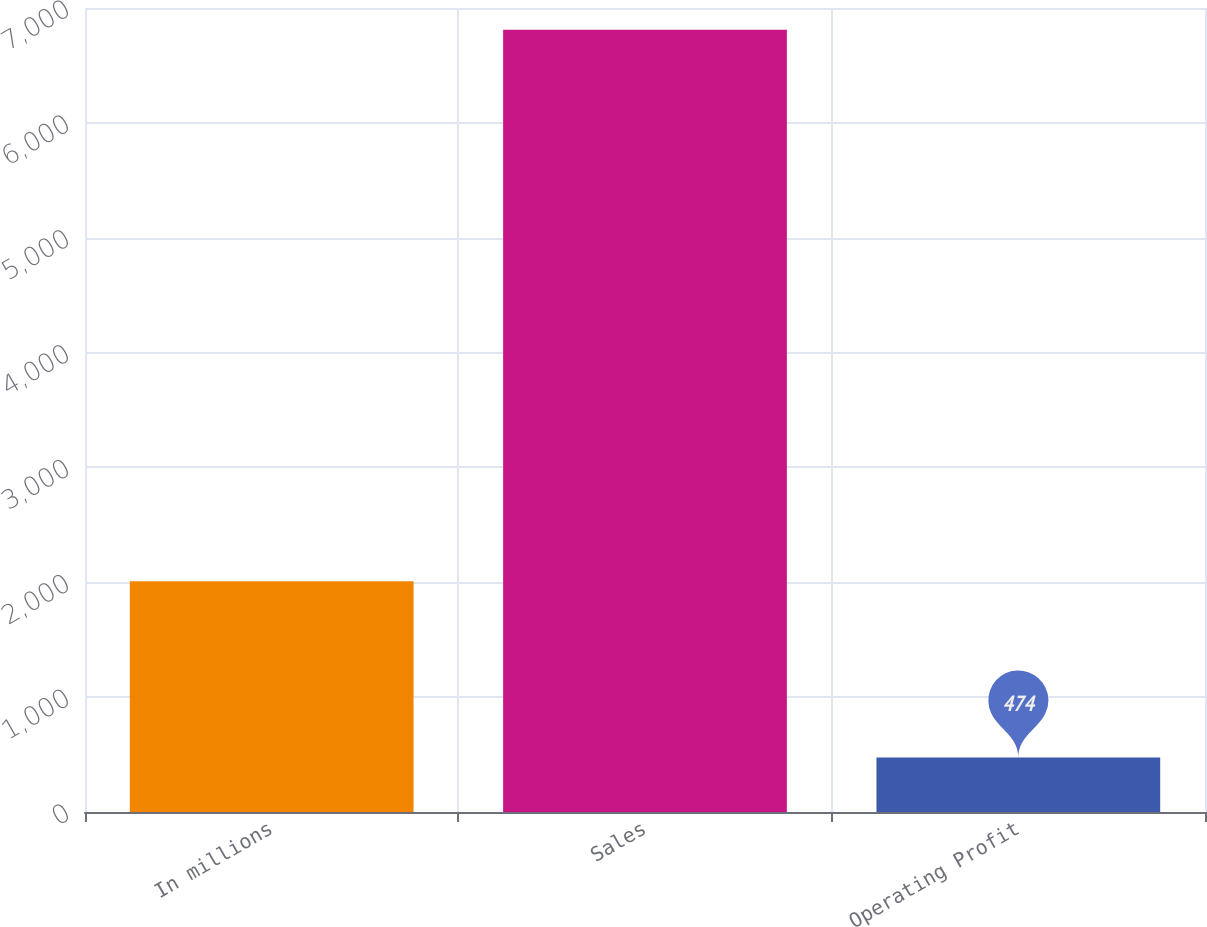<chart> <loc_0><loc_0><loc_500><loc_500><bar_chart><fcel>In millions<fcel>Sales<fcel>Operating Profit<nl><fcel>2008<fcel>6810<fcel>474<nl></chart> 